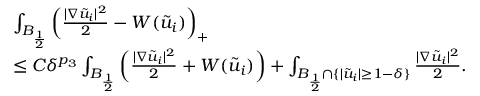Convert formula to latex. <formula><loc_0><loc_0><loc_500><loc_500>\begin{array} { r l } & { \int _ { B _ { \frac { 1 } { 2 } } } \left ( \frac { | \nabla \tilde { u } _ { i } | ^ { 2 } } { 2 } - W ( \tilde { u } _ { i } ) \right ) _ { + } } \\ & { \leq C { \delta ^ { p _ { 3 } } } \int _ { B _ { \frac { 1 } { 2 } } } \left ( \frac { | \nabla \tilde { u } _ { i } | ^ { 2 } } { 2 } + W ( \tilde { u } _ { i } ) \right ) + \int _ { B _ { \frac { 1 } { 2 } } \cap \{ | \tilde { u } _ { i } | \geq 1 - \delta \} } \frac { | \nabla \tilde { u } _ { i } | ^ { 2 } } { 2 } . } \end{array}</formula> 